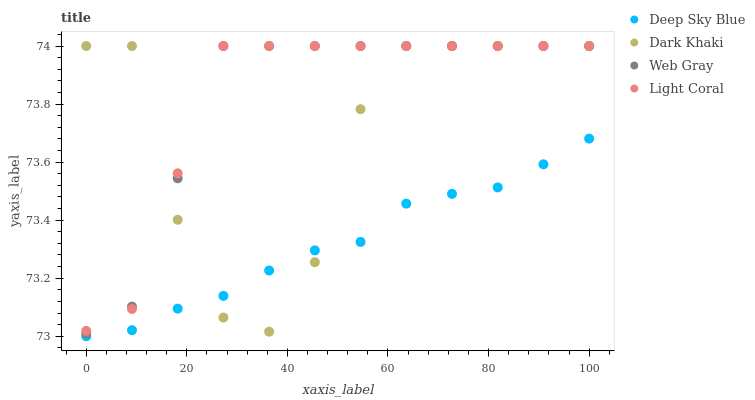Does Deep Sky Blue have the minimum area under the curve?
Answer yes or no. Yes. Does Light Coral have the maximum area under the curve?
Answer yes or no. Yes. Does Web Gray have the minimum area under the curve?
Answer yes or no. No. Does Web Gray have the maximum area under the curve?
Answer yes or no. No. Is Deep Sky Blue the smoothest?
Answer yes or no. Yes. Is Dark Khaki the roughest?
Answer yes or no. Yes. Is Light Coral the smoothest?
Answer yes or no. No. Is Light Coral the roughest?
Answer yes or no. No. Does Deep Sky Blue have the lowest value?
Answer yes or no. Yes. Does Web Gray have the lowest value?
Answer yes or no. No. Does Web Gray have the highest value?
Answer yes or no. Yes. Does Deep Sky Blue have the highest value?
Answer yes or no. No. Is Deep Sky Blue less than Light Coral?
Answer yes or no. Yes. Is Web Gray greater than Deep Sky Blue?
Answer yes or no. Yes. Does Dark Khaki intersect Light Coral?
Answer yes or no. Yes. Is Dark Khaki less than Light Coral?
Answer yes or no. No. Is Dark Khaki greater than Light Coral?
Answer yes or no. No. Does Deep Sky Blue intersect Light Coral?
Answer yes or no. No. 